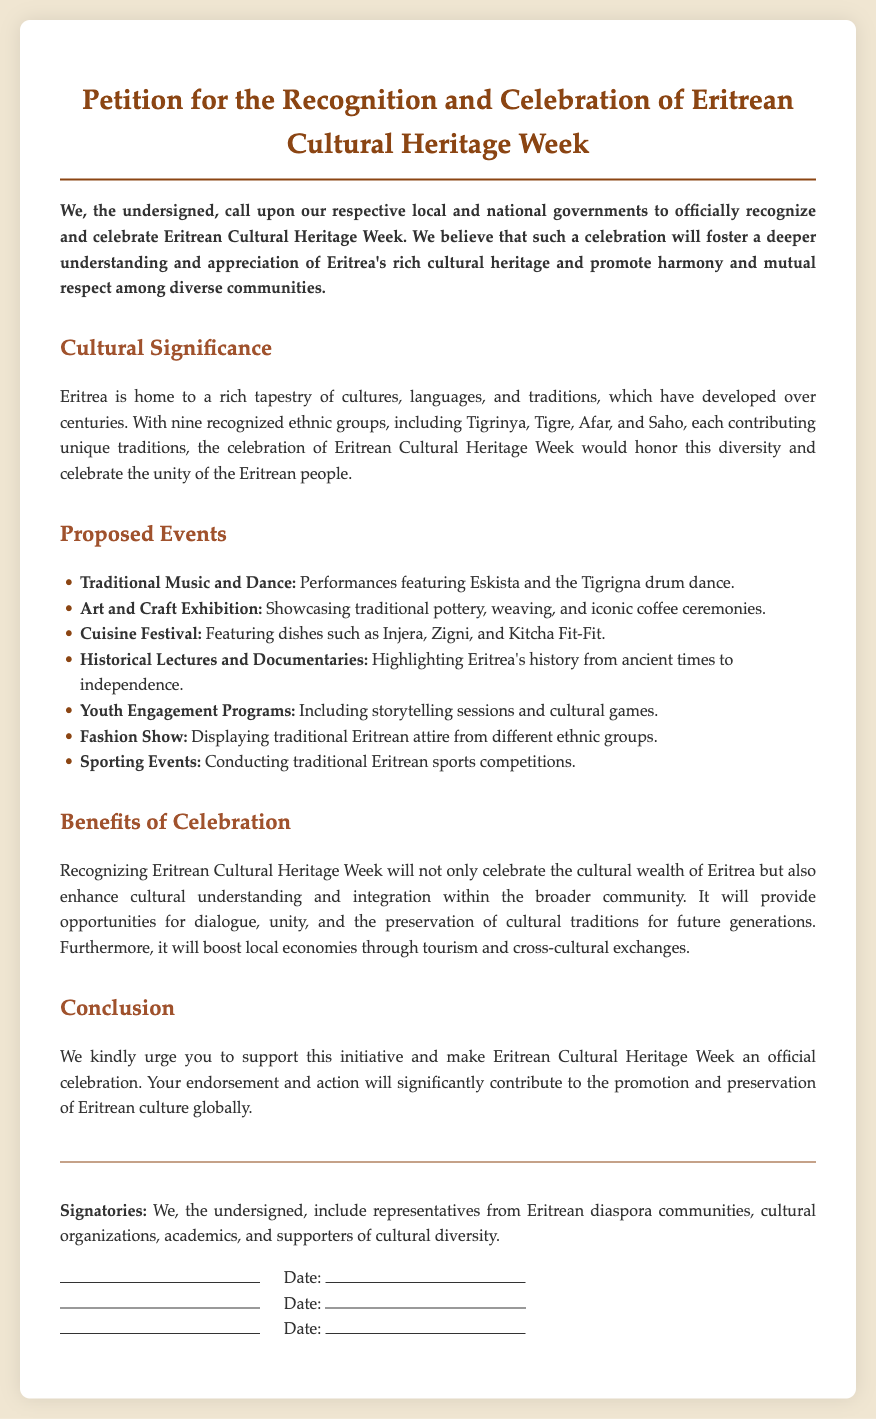What is the main purpose of the petition? The petition aims to officially recognize and celebrate Eritrean Cultural Heritage Week to foster understanding and appreciation of Eritrea's cultural heritage.
Answer: Official recognition and celebration of Eritrean Cultural Heritage Week How many ethnic groups are recognized in Eritrea? The document mentions that Eritrea has nine recognized ethnic groups.
Answer: Nine What is one proposed event mentioned in the document? The document lists various events, including traditional music and dance performances featuring Eskista.
Answer: Traditional Music and Dance What does the benefits section highlight? It emphasizes that celebrating Cultural Heritage Week will enhance cultural understanding and integration within the community.
Answer: Cultural understanding and integration Who are the signatories of the petition? The signatories include representatives from the Eritrean diaspora communities, cultural organizations, academics, and supporters of cultural diversity.
Answer: Representatives from Eritrean diaspora communities What type of cuisine is featured in the proposed events? The cuisine festival focuses on traditional Eritrean dishes.
Answer: Traditional Eritrean dishes What is the conclusion's request to the local and national governments? The conclusion urges the governments to support the initiative and officially celebrate Eritrean Cultural Heritage Week.
Answer: Support the initiative for celebration What will the celebration provide opportunities for? The celebration will provide opportunities for dialogue, unity, and the preservation of cultural traditions.
Answer: Dialogue, unity, and preservation of cultural traditions 